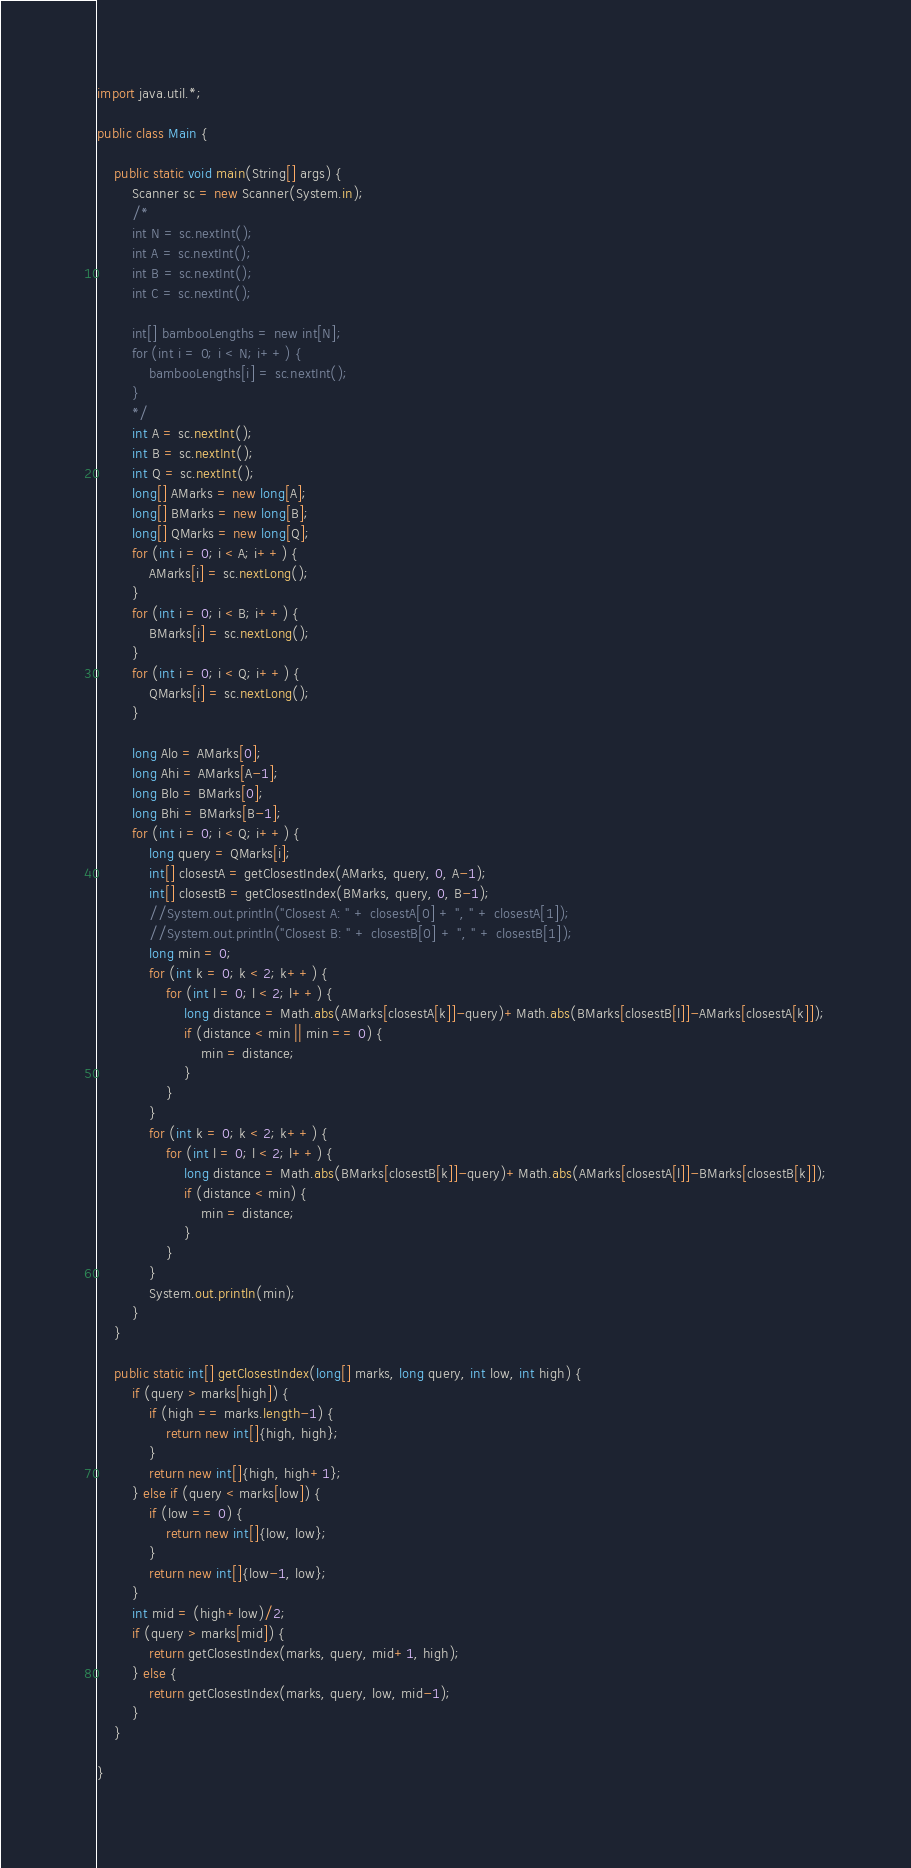<code> <loc_0><loc_0><loc_500><loc_500><_Java_>import java.util.*;

public class Main {
	
	public static void main(String[] args) {
		Scanner sc = new Scanner(System.in);
		/*
		int N = sc.nextInt();
		int A = sc.nextInt();
		int B = sc.nextInt();
		int C = sc.nextInt();
		
		int[] bambooLengths = new int[N];
		for (int i = 0; i < N; i++) {
			bambooLengths[i] = sc.nextInt();
		}
		*/
		int A = sc.nextInt();
		int B = sc.nextInt();
		int Q = sc.nextInt();
		long[] AMarks = new long[A];
		long[] BMarks = new long[B];
		long[] QMarks = new long[Q];
		for (int i = 0; i < A; i++) {
			AMarks[i] = sc.nextLong();
		}
		for (int i = 0; i < B; i++) {
			BMarks[i] = sc.nextLong();
		}
		for (int i = 0; i < Q; i++) {
			QMarks[i] = sc.nextLong();
		}
		
		long Alo = AMarks[0];
		long Ahi = AMarks[A-1];
		long Blo = BMarks[0];
		long Bhi = BMarks[B-1];
		for (int i = 0; i < Q; i++) {
			long query = QMarks[i];
			int[] closestA = getClosestIndex(AMarks, query, 0, A-1);
			int[] closestB = getClosestIndex(BMarks, query, 0, B-1);
			//System.out.println("Closest A: " + closestA[0] + ", " + closestA[1]);
			//System.out.println("Closest B: " + closestB[0] + ", " + closestB[1]);
			long min = 0;
			for (int k = 0; k < 2; k++) {
				for (int l = 0; l < 2; l++) {
					long distance = Math.abs(AMarks[closestA[k]]-query)+Math.abs(BMarks[closestB[l]]-AMarks[closestA[k]]);
					if (distance < min || min == 0) {
						min = distance;
					}
				}
			}
			for (int k = 0; k < 2; k++) {
				for (int l = 0; l < 2; l++) {
					long distance = Math.abs(BMarks[closestB[k]]-query)+Math.abs(AMarks[closestA[l]]-BMarks[closestB[k]]);
					if (distance < min) {
						min = distance;
					}
				}
			}
			System.out.println(min);
		}
    }
	
	public static int[] getClosestIndex(long[] marks, long query, int low, int high) {
		if (query > marks[high]) {
			if (high == marks.length-1) {
				return new int[]{high, high};
			}
			return new int[]{high, high+1};
		} else if (query < marks[low]) {
			if (low == 0) {
				return new int[]{low, low};
			}
			return new int[]{low-1, low};
		}
		int mid = (high+low)/2;
		if (query > marks[mid]) {
			return getClosestIndex(marks, query, mid+1, high);
		} else {
			return getClosestIndex(marks, query, low, mid-1);
		}
	}
  
}
</code> 